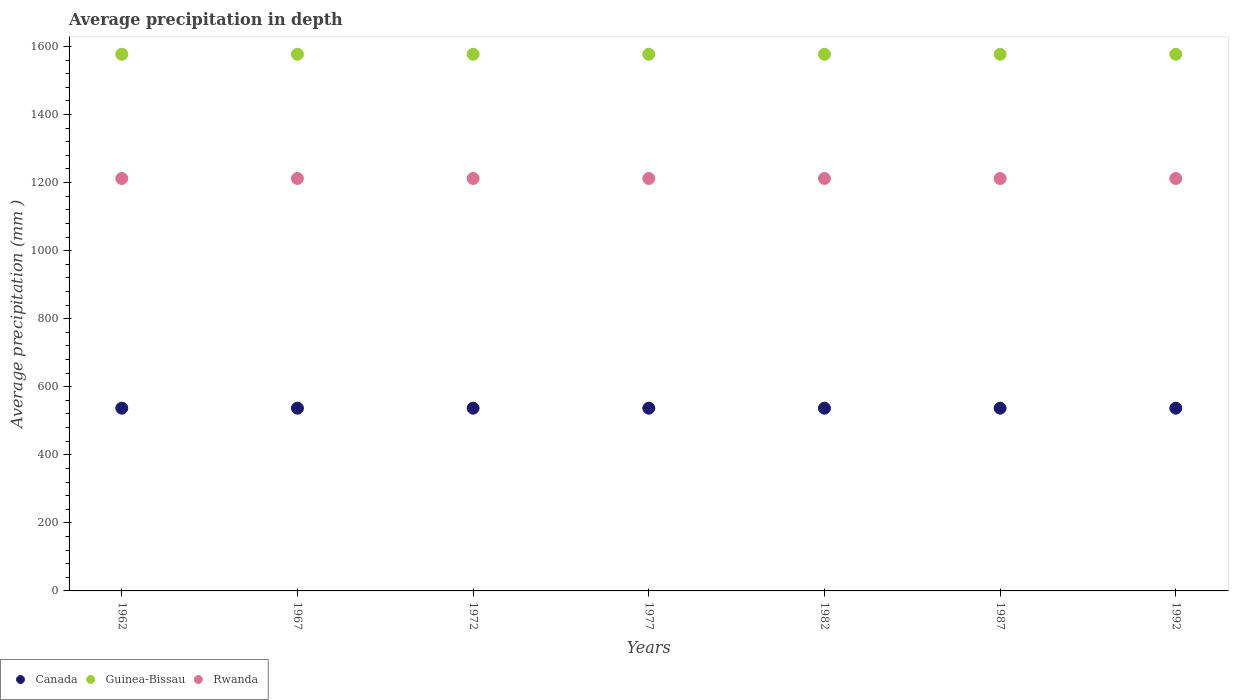How many different coloured dotlines are there?
Ensure brevity in your answer.  3. Is the number of dotlines equal to the number of legend labels?
Offer a very short reply. Yes. What is the average precipitation in Guinea-Bissau in 1977?
Provide a succinct answer. 1577. Across all years, what is the maximum average precipitation in Rwanda?
Provide a short and direct response. 1212. Across all years, what is the minimum average precipitation in Canada?
Your answer should be very brief. 537. In which year was the average precipitation in Rwanda maximum?
Make the answer very short. 1962. What is the total average precipitation in Canada in the graph?
Give a very brief answer. 3759. What is the difference between the average precipitation in Canada in 1982 and that in 1987?
Offer a terse response. 0. What is the difference between the average precipitation in Rwanda in 1967 and the average precipitation in Canada in 1977?
Offer a very short reply. 675. What is the average average precipitation in Canada per year?
Your answer should be compact. 537. In the year 1962, what is the difference between the average precipitation in Canada and average precipitation in Guinea-Bissau?
Provide a short and direct response. -1040. In how many years, is the average precipitation in Guinea-Bissau greater than 640 mm?
Provide a short and direct response. 7. What is the difference between the highest and the lowest average precipitation in Guinea-Bissau?
Provide a succinct answer. 0. Does the average precipitation in Canada monotonically increase over the years?
Offer a very short reply. No. Is the average precipitation in Guinea-Bissau strictly greater than the average precipitation in Canada over the years?
Offer a terse response. Yes. Is the average precipitation in Rwanda strictly less than the average precipitation in Guinea-Bissau over the years?
Ensure brevity in your answer.  Yes. How many dotlines are there?
Your answer should be very brief. 3. How many years are there in the graph?
Ensure brevity in your answer.  7. Are the values on the major ticks of Y-axis written in scientific E-notation?
Your response must be concise. No. Does the graph contain any zero values?
Your response must be concise. No. Does the graph contain grids?
Offer a very short reply. No. Where does the legend appear in the graph?
Offer a terse response. Bottom left. How many legend labels are there?
Offer a terse response. 3. What is the title of the graph?
Make the answer very short. Average precipitation in depth. What is the label or title of the X-axis?
Offer a terse response. Years. What is the label or title of the Y-axis?
Provide a short and direct response. Average precipitation (mm ). What is the Average precipitation (mm ) in Canada in 1962?
Your answer should be compact. 537. What is the Average precipitation (mm ) in Guinea-Bissau in 1962?
Make the answer very short. 1577. What is the Average precipitation (mm ) in Rwanda in 1962?
Offer a terse response. 1212. What is the Average precipitation (mm ) of Canada in 1967?
Your answer should be very brief. 537. What is the Average precipitation (mm ) of Guinea-Bissau in 1967?
Make the answer very short. 1577. What is the Average precipitation (mm ) of Rwanda in 1967?
Your answer should be very brief. 1212. What is the Average precipitation (mm ) in Canada in 1972?
Keep it short and to the point. 537. What is the Average precipitation (mm ) in Guinea-Bissau in 1972?
Make the answer very short. 1577. What is the Average precipitation (mm ) of Rwanda in 1972?
Provide a succinct answer. 1212. What is the Average precipitation (mm ) in Canada in 1977?
Give a very brief answer. 537. What is the Average precipitation (mm ) of Guinea-Bissau in 1977?
Offer a very short reply. 1577. What is the Average precipitation (mm ) in Rwanda in 1977?
Your answer should be very brief. 1212. What is the Average precipitation (mm ) in Canada in 1982?
Make the answer very short. 537. What is the Average precipitation (mm ) in Guinea-Bissau in 1982?
Offer a terse response. 1577. What is the Average precipitation (mm ) in Rwanda in 1982?
Your answer should be very brief. 1212. What is the Average precipitation (mm ) of Canada in 1987?
Provide a succinct answer. 537. What is the Average precipitation (mm ) in Guinea-Bissau in 1987?
Provide a short and direct response. 1577. What is the Average precipitation (mm ) of Rwanda in 1987?
Keep it short and to the point. 1212. What is the Average precipitation (mm ) in Canada in 1992?
Provide a succinct answer. 537. What is the Average precipitation (mm ) in Guinea-Bissau in 1992?
Provide a short and direct response. 1577. What is the Average precipitation (mm ) in Rwanda in 1992?
Provide a short and direct response. 1212. Across all years, what is the maximum Average precipitation (mm ) of Canada?
Give a very brief answer. 537. Across all years, what is the maximum Average precipitation (mm ) in Guinea-Bissau?
Your answer should be very brief. 1577. Across all years, what is the maximum Average precipitation (mm ) in Rwanda?
Your answer should be compact. 1212. Across all years, what is the minimum Average precipitation (mm ) in Canada?
Offer a very short reply. 537. Across all years, what is the minimum Average precipitation (mm ) in Guinea-Bissau?
Make the answer very short. 1577. Across all years, what is the minimum Average precipitation (mm ) of Rwanda?
Ensure brevity in your answer.  1212. What is the total Average precipitation (mm ) of Canada in the graph?
Ensure brevity in your answer.  3759. What is the total Average precipitation (mm ) of Guinea-Bissau in the graph?
Provide a short and direct response. 1.10e+04. What is the total Average precipitation (mm ) of Rwanda in the graph?
Offer a very short reply. 8484. What is the difference between the Average precipitation (mm ) of Canada in 1962 and that in 1967?
Your answer should be very brief. 0. What is the difference between the Average precipitation (mm ) of Guinea-Bissau in 1962 and that in 1967?
Offer a terse response. 0. What is the difference between the Average precipitation (mm ) of Guinea-Bissau in 1962 and that in 1972?
Offer a terse response. 0. What is the difference between the Average precipitation (mm ) of Canada in 1962 and that in 1977?
Keep it short and to the point. 0. What is the difference between the Average precipitation (mm ) of Guinea-Bissau in 1962 and that in 1977?
Ensure brevity in your answer.  0. What is the difference between the Average precipitation (mm ) of Guinea-Bissau in 1962 and that in 1982?
Your answer should be compact. 0. What is the difference between the Average precipitation (mm ) in Canada in 1962 and that in 1987?
Make the answer very short. 0. What is the difference between the Average precipitation (mm ) in Guinea-Bissau in 1962 and that in 1987?
Offer a very short reply. 0. What is the difference between the Average precipitation (mm ) in Canada in 1962 and that in 1992?
Ensure brevity in your answer.  0. What is the difference between the Average precipitation (mm ) in Rwanda in 1962 and that in 1992?
Give a very brief answer. 0. What is the difference between the Average precipitation (mm ) of Canada in 1967 and that in 1972?
Your response must be concise. 0. What is the difference between the Average precipitation (mm ) in Canada in 1967 and that in 1977?
Your answer should be compact. 0. What is the difference between the Average precipitation (mm ) in Guinea-Bissau in 1967 and that in 1977?
Your answer should be compact. 0. What is the difference between the Average precipitation (mm ) of Canada in 1967 and that in 1987?
Keep it short and to the point. 0. What is the difference between the Average precipitation (mm ) in Guinea-Bissau in 1967 and that in 1987?
Give a very brief answer. 0. What is the difference between the Average precipitation (mm ) of Rwanda in 1967 and that in 1987?
Your response must be concise. 0. What is the difference between the Average precipitation (mm ) in Rwanda in 1967 and that in 1992?
Your answer should be very brief. 0. What is the difference between the Average precipitation (mm ) of Guinea-Bissau in 1972 and that in 1977?
Provide a short and direct response. 0. What is the difference between the Average precipitation (mm ) of Rwanda in 1972 and that in 1977?
Ensure brevity in your answer.  0. What is the difference between the Average precipitation (mm ) in Canada in 1972 and that in 1982?
Offer a very short reply. 0. What is the difference between the Average precipitation (mm ) in Guinea-Bissau in 1972 and that in 1982?
Ensure brevity in your answer.  0. What is the difference between the Average precipitation (mm ) in Rwanda in 1972 and that in 1982?
Ensure brevity in your answer.  0. What is the difference between the Average precipitation (mm ) in Canada in 1972 and that in 1992?
Your answer should be very brief. 0. What is the difference between the Average precipitation (mm ) in Guinea-Bissau in 1972 and that in 1992?
Offer a terse response. 0. What is the difference between the Average precipitation (mm ) in Rwanda in 1972 and that in 1992?
Provide a succinct answer. 0. What is the difference between the Average precipitation (mm ) in Rwanda in 1977 and that in 1982?
Offer a terse response. 0. What is the difference between the Average precipitation (mm ) of Canada in 1977 and that in 1987?
Your response must be concise. 0. What is the difference between the Average precipitation (mm ) of Guinea-Bissau in 1977 and that in 1987?
Your answer should be very brief. 0. What is the difference between the Average precipitation (mm ) of Canada in 1977 and that in 1992?
Your answer should be compact. 0. What is the difference between the Average precipitation (mm ) of Rwanda in 1977 and that in 1992?
Offer a very short reply. 0. What is the difference between the Average precipitation (mm ) in Guinea-Bissau in 1982 and that in 1987?
Ensure brevity in your answer.  0. What is the difference between the Average precipitation (mm ) of Canada in 1987 and that in 1992?
Offer a very short reply. 0. What is the difference between the Average precipitation (mm ) in Guinea-Bissau in 1987 and that in 1992?
Your answer should be compact. 0. What is the difference between the Average precipitation (mm ) of Rwanda in 1987 and that in 1992?
Your answer should be very brief. 0. What is the difference between the Average precipitation (mm ) of Canada in 1962 and the Average precipitation (mm ) of Guinea-Bissau in 1967?
Make the answer very short. -1040. What is the difference between the Average precipitation (mm ) of Canada in 1962 and the Average precipitation (mm ) of Rwanda in 1967?
Your response must be concise. -675. What is the difference between the Average precipitation (mm ) in Guinea-Bissau in 1962 and the Average precipitation (mm ) in Rwanda in 1967?
Give a very brief answer. 365. What is the difference between the Average precipitation (mm ) of Canada in 1962 and the Average precipitation (mm ) of Guinea-Bissau in 1972?
Make the answer very short. -1040. What is the difference between the Average precipitation (mm ) in Canada in 1962 and the Average precipitation (mm ) in Rwanda in 1972?
Provide a short and direct response. -675. What is the difference between the Average precipitation (mm ) in Guinea-Bissau in 1962 and the Average precipitation (mm ) in Rwanda in 1972?
Offer a terse response. 365. What is the difference between the Average precipitation (mm ) in Canada in 1962 and the Average precipitation (mm ) in Guinea-Bissau in 1977?
Your answer should be compact. -1040. What is the difference between the Average precipitation (mm ) in Canada in 1962 and the Average precipitation (mm ) in Rwanda in 1977?
Provide a short and direct response. -675. What is the difference between the Average precipitation (mm ) in Guinea-Bissau in 1962 and the Average precipitation (mm ) in Rwanda in 1977?
Your answer should be very brief. 365. What is the difference between the Average precipitation (mm ) of Canada in 1962 and the Average precipitation (mm ) of Guinea-Bissau in 1982?
Ensure brevity in your answer.  -1040. What is the difference between the Average precipitation (mm ) in Canada in 1962 and the Average precipitation (mm ) in Rwanda in 1982?
Make the answer very short. -675. What is the difference between the Average precipitation (mm ) of Guinea-Bissau in 1962 and the Average precipitation (mm ) of Rwanda in 1982?
Your response must be concise. 365. What is the difference between the Average precipitation (mm ) in Canada in 1962 and the Average precipitation (mm ) in Guinea-Bissau in 1987?
Provide a short and direct response. -1040. What is the difference between the Average precipitation (mm ) of Canada in 1962 and the Average precipitation (mm ) of Rwanda in 1987?
Your answer should be very brief. -675. What is the difference between the Average precipitation (mm ) of Guinea-Bissau in 1962 and the Average precipitation (mm ) of Rwanda in 1987?
Offer a very short reply. 365. What is the difference between the Average precipitation (mm ) in Canada in 1962 and the Average precipitation (mm ) in Guinea-Bissau in 1992?
Give a very brief answer. -1040. What is the difference between the Average precipitation (mm ) of Canada in 1962 and the Average precipitation (mm ) of Rwanda in 1992?
Your response must be concise. -675. What is the difference between the Average precipitation (mm ) of Guinea-Bissau in 1962 and the Average precipitation (mm ) of Rwanda in 1992?
Ensure brevity in your answer.  365. What is the difference between the Average precipitation (mm ) of Canada in 1967 and the Average precipitation (mm ) of Guinea-Bissau in 1972?
Give a very brief answer. -1040. What is the difference between the Average precipitation (mm ) in Canada in 1967 and the Average precipitation (mm ) in Rwanda in 1972?
Your answer should be very brief. -675. What is the difference between the Average precipitation (mm ) in Guinea-Bissau in 1967 and the Average precipitation (mm ) in Rwanda in 1972?
Keep it short and to the point. 365. What is the difference between the Average precipitation (mm ) in Canada in 1967 and the Average precipitation (mm ) in Guinea-Bissau in 1977?
Ensure brevity in your answer.  -1040. What is the difference between the Average precipitation (mm ) in Canada in 1967 and the Average precipitation (mm ) in Rwanda in 1977?
Your response must be concise. -675. What is the difference between the Average precipitation (mm ) in Guinea-Bissau in 1967 and the Average precipitation (mm ) in Rwanda in 1977?
Offer a very short reply. 365. What is the difference between the Average precipitation (mm ) in Canada in 1967 and the Average precipitation (mm ) in Guinea-Bissau in 1982?
Give a very brief answer. -1040. What is the difference between the Average precipitation (mm ) of Canada in 1967 and the Average precipitation (mm ) of Rwanda in 1982?
Keep it short and to the point. -675. What is the difference between the Average precipitation (mm ) of Guinea-Bissau in 1967 and the Average precipitation (mm ) of Rwanda in 1982?
Provide a succinct answer. 365. What is the difference between the Average precipitation (mm ) of Canada in 1967 and the Average precipitation (mm ) of Guinea-Bissau in 1987?
Provide a succinct answer. -1040. What is the difference between the Average precipitation (mm ) of Canada in 1967 and the Average precipitation (mm ) of Rwanda in 1987?
Offer a terse response. -675. What is the difference between the Average precipitation (mm ) in Guinea-Bissau in 1967 and the Average precipitation (mm ) in Rwanda in 1987?
Provide a succinct answer. 365. What is the difference between the Average precipitation (mm ) of Canada in 1967 and the Average precipitation (mm ) of Guinea-Bissau in 1992?
Keep it short and to the point. -1040. What is the difference between the Average precipitation (mm ) in Canada in 1967 and the Average precipitation (mm ) in Rwanda in 1992?
Offer a very short reply. -675. What is the difference between the Average precipitation (mm ) in Guinea-Bissau in 1967 and the Average precipitation (mm ) in Rwanda in 1992?
Your answer should be very brief. 365. What is the difference between the Average precipitation (mm ) of Canada in 1972 and the Average precipitation (mm ) of Guinea-Bissau in 1977?
Your response must be concise. -1040. What is the difference between the Average precipitation (mm ) in Canada in 1972 and the Average precipitation (mm ) in Rwanda in 1977?
Give a very brief answer. -675. What is the difference between the Average precipitation (mm ) in Guinea-Bissau in 1972 and the Average precipitation (mm ) in Rwanda in 1977?
Provide a succinct answer. 365. What is the difference between the Average precipitation (mm ) of Canada in 1972 and the Average precipitation (mm ) of Guinea-Bissau in 1982?
Ensure brevity in your answer.  -1040. What is the difference between the Average precipitation (mm ) in Canada in 1972 and the Average precipitation (mm ) in Rwanda in 1982?
Offer a very short reply. -675. What is the difference between the Average precipitation (mm ) in Guinea-Bissau in 1972 and the Average precipitation (mm ) in Rwanda in 1982?
Keep it short and to the point. 365. What is the difference between the Average precipitation (mm ) in Canada in 1972 and the Average precipitation (mm ) in Guinea-Bissau in 1987?
Make the answer very short. -1040. What is the difference between the Average precipitation (mm ) of Canada in 1972 and the Average precipitation (mm ) of Rwanda in 1987?
Give a very brief answer. -675. What is the difference between the Average precipitation (mm ) in Guinea-Bissau in 1972 and the Average precipitation (mm ) in Rwanda in 1987?
Make the answer very short. 365. What is the difference between the Average precipitation (mm ) of Canada in 1972 and the Average precipitation (mm ) of Guinea-Bissau in 1992?
Offer a very short reply. -1040. What is the difference between the Average precipitation (mm ) of Canada in 1972 and the Average precipitation (mm ) of Rwanda in 1992?
Your answer should be very brief. -675. What is the difference between the Average precipitation (mm ) of Guinea-Bissau in 1972 and the Average precipitation (mm ) of Rwanda in 1992?
Offer a very short reply. 365. What is the difference between the Average precipitation (mm ) of Canada in 1977 and the Average precipitation (mm ) of Guinea-Bissau in 1982?
Give a very brief answer. -1040. What is the difference between the Average precipitation (mm ) in Canada in 1977 and the Average precipitation (mm ) in Rwanda in 1982?
Keep it short and to the point. -675. What is the difference between the Average precipitation (mm ) of Guinea-Bissau in 1977 and the Average precipitation (mm ) of Rwanda in 1982?
Your answer should be compact. 365. What is the difference between the Average precipitation (mm ) of Canada in 1977 and the Average precipitation (mm ) of Guinea-Bissau in 1987?
Your answer should be very brief. -1040. What is the difference between the Average precipitation (mm ) of Canada in 1977 and the Average precipitation (mm ) of Rwanda in 1987?
Offer a terse response. -675. What is the difference between the Average precipitation (mm ) in Guinea-Bissau in 1977 and the Average precipitation (mm ) in Rwanda in 1987?
Offer a terse response. 365. What is the difference between the Average precipitation (mm ) of Canada in 1977 and the Average precipitation (mm ) of Guinea-Bissau in 1992?
Ensure brevity in your answer.  -1040. What is the difference between the Average precipitation (mm ) of Canada in 1977 and the Average precipitation (mm ) of Rwanda in 1992?
Offer a terse response. -675. What is the difference between the Average precipitation (mm ) of Guinea-Bissau in 1977 and the Average precipitation (mm ) of Rwanda in 1992?
Your answer should be compact. 365. What is the difference between the Average precipitation (mm ) of Canada in 1982 and the Average precipitation (mm ) of Guinea-Bissau in 1987?
Ensure brevity in your answer.  -1040. What is the difference between the Average precipitation (mm ) in Canada in 1982 and the Average precipitation (mm ) in Rwanda in 1987?
Make the answer very short. -675. What is the difference between the Average precipitation (mm ) in Guinea-Bissau in 1982 and the Average precipitation (mm ) in Rwanda in 1987?
Your response must be concise. 365. What is the difference between the Average precipitation (mm ) of Canada in 1982 and the Average precipitation (mm ) of Guinea-Bissau in 1992?
Ensure brevity in your answer.  -1040. What is the difference between the Average precipitation (mm ) in Canada in 1982 and the Average precipitation (mm ) in Rwanda in 1992?
Offer a very short reply. -675. What is the difference between the Average precipitation (mm ) of Guinea-Bissau in 1982 and the Average precipitation (mm ) of Rwanda in 1992?
Keep it short and to the point. 365. What is the difference between the Average precipitation (mm ) in Canada in 1987 and the Average precipitation (mm ) in Guinea-Bissau in 1992?
Keep it short and to the point. -1040. What is the difference between the Average precipitation (mm ) of Canada in 1987 and the Average precipitation (mm ) of Rwanda in 1992?
Keep it short and to the point. -675. What is the difference between the Average precipitation (mm ) of Guinea-Bissau in 1987 and the Average precipitation (mm ) of Rwanda in 1992?
Provide a short and direct response. 365. What is the average Average precipitation (mm ) of Canada per year?
Your answer should be compact. 537. What is the average Average precipitation (mm ) of Guinea-Bissau per year?
Provide a short and direct response. 1577. What is the average Average precipitation (mm ) in Rwanda per year?
Offer a very short reply. 1212. In the year 1962, what is the difference between the Average precipitation (mm ) in Canada and Average precipitation (mm ) in Guinea-Bissau?
Provide a succinct answer. -1040. In the year 1962, what is the difference between the Average precipitation (mm ) of Canada and Average precipitation (mm ) of Rwanda?
Your answer should be compact. -675. In the year 1962, what is the difference between the Average precipitation (mm ) of Guinea-Bissau and Average precipitation (mm ) of Rwanda?
Offer a terse response. 365. In the year 1967, what is the difference between the Average precipitation (mm ) of Canada and Average precipitation (mm ) of Guinea-Bissau?
Provide a short and direct response. -1040. In the year 1967, what is the difference between the Average precipitation (mm ) of Canada and Average precipitation (mm ) of Rwanda?
Provide a short and direct response. -675. In the year 1967, what is the difference between the Average precipitation (mm ) in Guinea-Bissau and Average precipitation (mm ) in Rwanda?
Keep it short and to the point. 365. In the year 1972, what is the difference between the Average precipitation (mm ) of Canada and Average precipitation (mm ) of Guinea-Bissau?
Offer a very short reply. -1040. In the year 1972, what is the difference between the Average precipitation (mm ) of Canada and Average precipitation (mm ) of Rwanda?
Your answer should be compact. -675. In the year 1972, what is the difference between the Average precipitation (mm ) of Guinea-Bissau and Average precipitation (mm ) of Rwanda?
Give a very brief answer. 365. In the year 1977, what is the difference between the Average precipitation (mm ) in Canada and Average precipitation (mm ) in Guinea-Bissau?
Keep it short and to the point. -1040. In the year 1977, what is the difference between the Average precipitation (mm ) of Canada and Average precipitation (mm ) of Rwanda?
Your answer should be compact. -675. In the year 1977, what is the difference between the Average precipitation (mm ) of Guinea-Bissau and Average precipitation (mm ) of Rwanda?
Your response must be concise. 365. In the year 1982, what is the difference between the Average precipitation (mm ) in Canada and Average precipitation (mm ) in Guinea-Bissau?
Your answer should be compact. -1040. In the year 1982, what is the difference between the Average precipitation (mm ) in Canada and Average precipitation (mm ) in Rwanda?
Ensure brevity in your answer.  -675. In the year 1982, what is the difference between the Average precipitation (mm ) in Guinea-Bissau and Average precipitation (mm ) in Rwanda?
Your response must be concise. 365. In the year 1987, what is the difference between the Average precipitation (mm ) of Canada and Average precipitation (mm ) of Guinea-Bissau?
Your answer should be very brief. -1040. In the year 1987, what is the difference between the Average precipitation (mm ) of Canada and Average precipitation (mm ) of Rwanda?
Provide a short and direct response. -675. In the year 1987, what is the difference between the Average precipitation (mm ) in Guinea-Bissau and Average precipitation (mm ) in Rwanda?
Offer a terse response. 365. In the year 1992, what is the difference between the Average precipitation (mm ) in Canada and Average precipitation (mm ) in Guinea-Bissau?
Offer a very short reply. -1040. In the year 1992, what is the difference between the Average precipitation (mm ) in Canada and Average precipitation (mm ) in Rwanda?
Offer a very short reply. -675. In the year 1992, what is the difference between the Average precipitation (mm ) of Guinea-Bissau and Average precipitation (mm ) of Rwanda?
Offer a very short reply. 365. What is the ratio of the Average precipitation (mm ) of Rwanda in 1962 to that in 1967?
Your answer should be very brief. 1. What is the ratio of the Average precipitation (mm ) in Canada in 1962 to that in 1972?
Your answer should be compact. 1. What is the ratio of the Average precipitation (mm ) of Guinea-Bissau in 1962 to that in 1972?
Offer a terse response. 1. What is the ratio of the Average precipitation (mm ) in Canada in 1962 to that in 1977?
Make the answer very short. 1. What is the ratio of the Average precipitation (mm ) of Guinea-Bissau in 1962 to that in 1977?
Your response must be concise. 1. What is the ratio of the Average precipitation (mm ) in Rwanda in 1962 to that in 1977?
Give a very brief answer. 1. What is the ratio of the Average precipitation (mm ) of Canada in 1962 to that in 1982?
Provide a short and direct response. 1. What is the ratio of the Average precipitation (mm ) of Rwanda in 1962 to that in 1982?
Your answer should be compact. 1. What is the ratio of the Average precipitation (mm ) in Canada in 1962 to that in 1987?
Your answer should be very brief. 1. What is the ratio of the Average precipitation (mm ) in Rwanda in 1962 to that in 1987?
Your answer should be compact. 1. What is the ratio of the Average precipitation (mm ) in Guinea-Bissau in 1962 to that in 1992?
Give a very brief answer. 1. What is the ratio of the Average precipitation (mm ) of Canada in 1967 to that in 1972?
Provide a succinct answer. 1. What is the ratio of the Average precipitation (mm ) of Guinea-Bissau in 1967 to that in 1972?
Provide a succinct answer. 1. What is the ratio of the Average precipitation (mm ) in Rwanda in 1967 to that in 1972?
Your answer should be compact. 1. What is the ratio of the Average precipitation (mm ) in Canada in 1967 to that in 1977?
Offer a terse response. 1. What is the ratio of the Average precipitation (mm ) in Rwanda in 1967 to that in 1977?
Keep it short and to the point. 1. What is the ratio of the Average precipitation (mm ) of Canada in 1967 to that in 1982?
Offer a very short reply. 1. What is the ratio of the Average precipitation (mm ) of Rwanda in 1967 to that in 1982?
Your answer should be very brief. 1. What is the ratio of the Average precipitation (mm ) of Canada in 1967 to that in 1987?
Your response must be concise. 1. What is the ratio of the Average precipitation (mm ) in Guinea-Bissau in 1967 to that in 1987?
Keep it short and to the point. 1. What is the ratio of the Average precipitation (mm ) of Rwanda in 1967 to that in 1987?
Offer a terse response. 1. What is the ratio of the Average precipitation (mm ) in Canada in 1967 to that in 1992?
Ensure brevity in your answer.  1. What is the ratio of the Average precipitation (mm ) of Guinea-Bissau in 1967 to that in 1992?
Offer a very short reply. 1. What is the ratio of the Average precipitation (mm ) in Rwanda in 1967 to that in 1992?
Give a very brief answer. 1. What is the ratio of the Average precipitation (mm ) in Canada in 1972 to that in 1982?
Your answer should be very brief. 1. What is the ratio of the Average precipitation (mm ) of Guinea-Bissau in 1972 to that in 1982?
Offer a terse response. 1. What is the ratio of the Average precipitation (mm ) in Rwanda in 1972 to that in 1982?
Provide a short and direct response. 1. What is the ratio of the Average precipitation (mm ) of Canada in 1972 to that in 1987?
Keep it short and to the point. 1. What is the ratio of the Average precipitation (mm ) in Guinea-Bissau in 1972 to that in 1987?
Give a very brief answer. 1. What is the ratio of the Average precipitation (mm ) of Rwanda in 1972 to that in 1987?
Ensure brevity in your answer.  1. What is the ratio of the Average precipitation (mm ) in Canada in 1972 to that in 1992?
Your answer should be compact. 1. What is the ratio of the Average precipitation (mm ) in Guinea-Bissau in 1977 to that in 1982?
Offer a terse response. 1. What is the ratio of the Average precipitation (mm ) of Rwanda in 1977 to that in 1982?
Offer a terse response. 1. What is the ratio of the Average precipitation (mm ) in Guinea-Bissau in 1977 to that in 1987?
Offer a very short reply. 1. What is the ratio of the Average precipitation (mm ) in Rwanda in 1977 to that in 1987?
Provide a succinct answer. 1. What is the ratio of the Average precipitation (mm ) of Canada in 1977 to that in 1992?
Provide a succinct answer. 1. What is the ratio of the Average precipitation (mm ) of Guinea-Bissau in 1977 to that in 1992?
Give a very brief answer. 1. What is the ratio of the Average precipitation (mm ) in Rwanda in 1977 to that in 1992?
Ensure brevity in your answer.  1. What is the ratio of the Average precipitation (mm ) of Guinea-Bissau in 1982 to that in 1987?
Your answer should be compact. 1. What is the ratio of the Average precipitation (mm ) of Rwanda in 1982 to that in 1987?
Your answer should be compact. 1. What is the ratio of the Average precipitation (mm ) in Guinea-Bissau in 1982 to that in 1992?
Provide a short and direct response. 1. What is the ratio of the Average precipitation (mm ) of Canada in 1987 to that in 1992?
Provide a succinct answer. 1. What is the ratio of the Average precipitation (mm ) of Guinea-Bissau in 1987 to that in 1992?
Ensure brevity in your answer.  1. What is the ratio of the Average precipitation (mm ) of Rwanda in 1987 to that in 1992?
Ensure brevity in your answer.  1. What is the difference between the highest and the second highest Average precipitation (mm ) in Canada?
Keep it short and to the point. 0. What is the difference between the highest and the second highest Average precipitation (mm ) of Guinea-Bissau?
Ensure brevity in your answer.  0. What is the difference between the highest and the lowest Average precipitation (mm ) in Canada?
Provide a short and direct response. 0. What is the difference between the highest and the lowest Average precipitation (mm ) in Rwanda?
Provide a succinct answer. 0. 